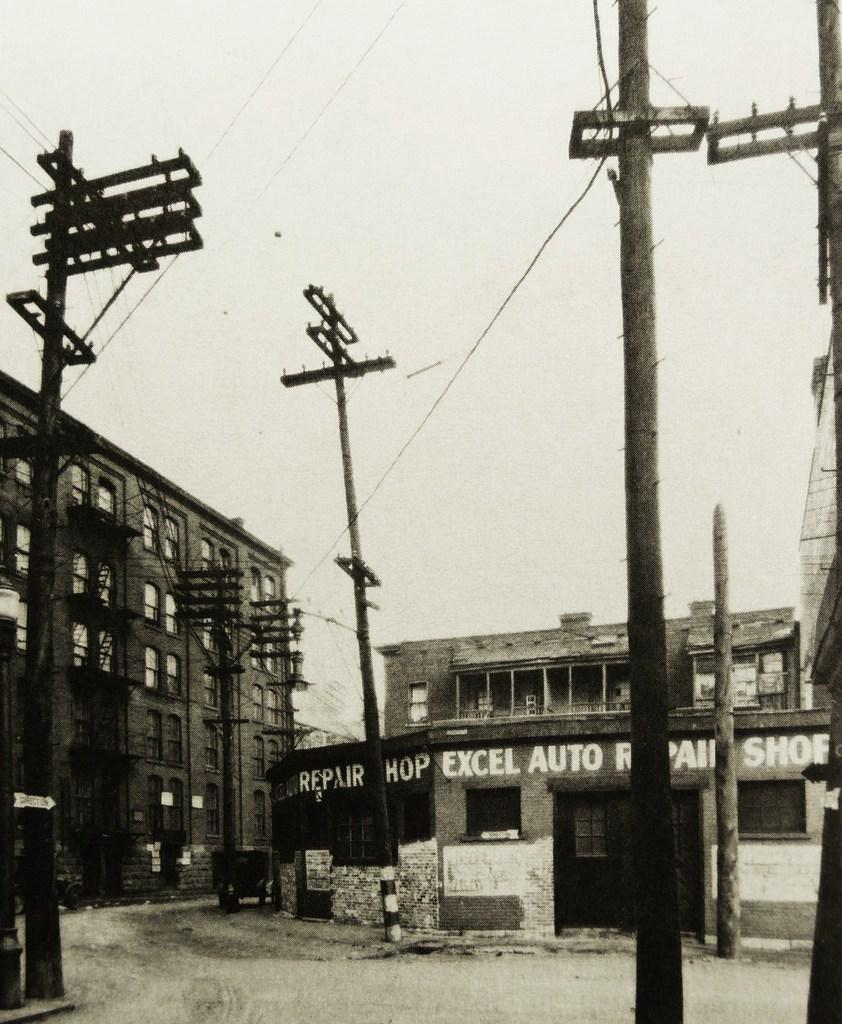What is the color scheme of the image? The image is black and white. What type of structures can be seen in the image? There are electrical poles and buildings in the image. Can you describe any specific details about one of the buildings? One of the buildings has text on it. How many chickens are sitting on the electrical poles in the image? There are no chickens present in the image; it features electrical poles and buildings. What type of carriage can be seen transporting people in the image? There is no carriage present in the image. 